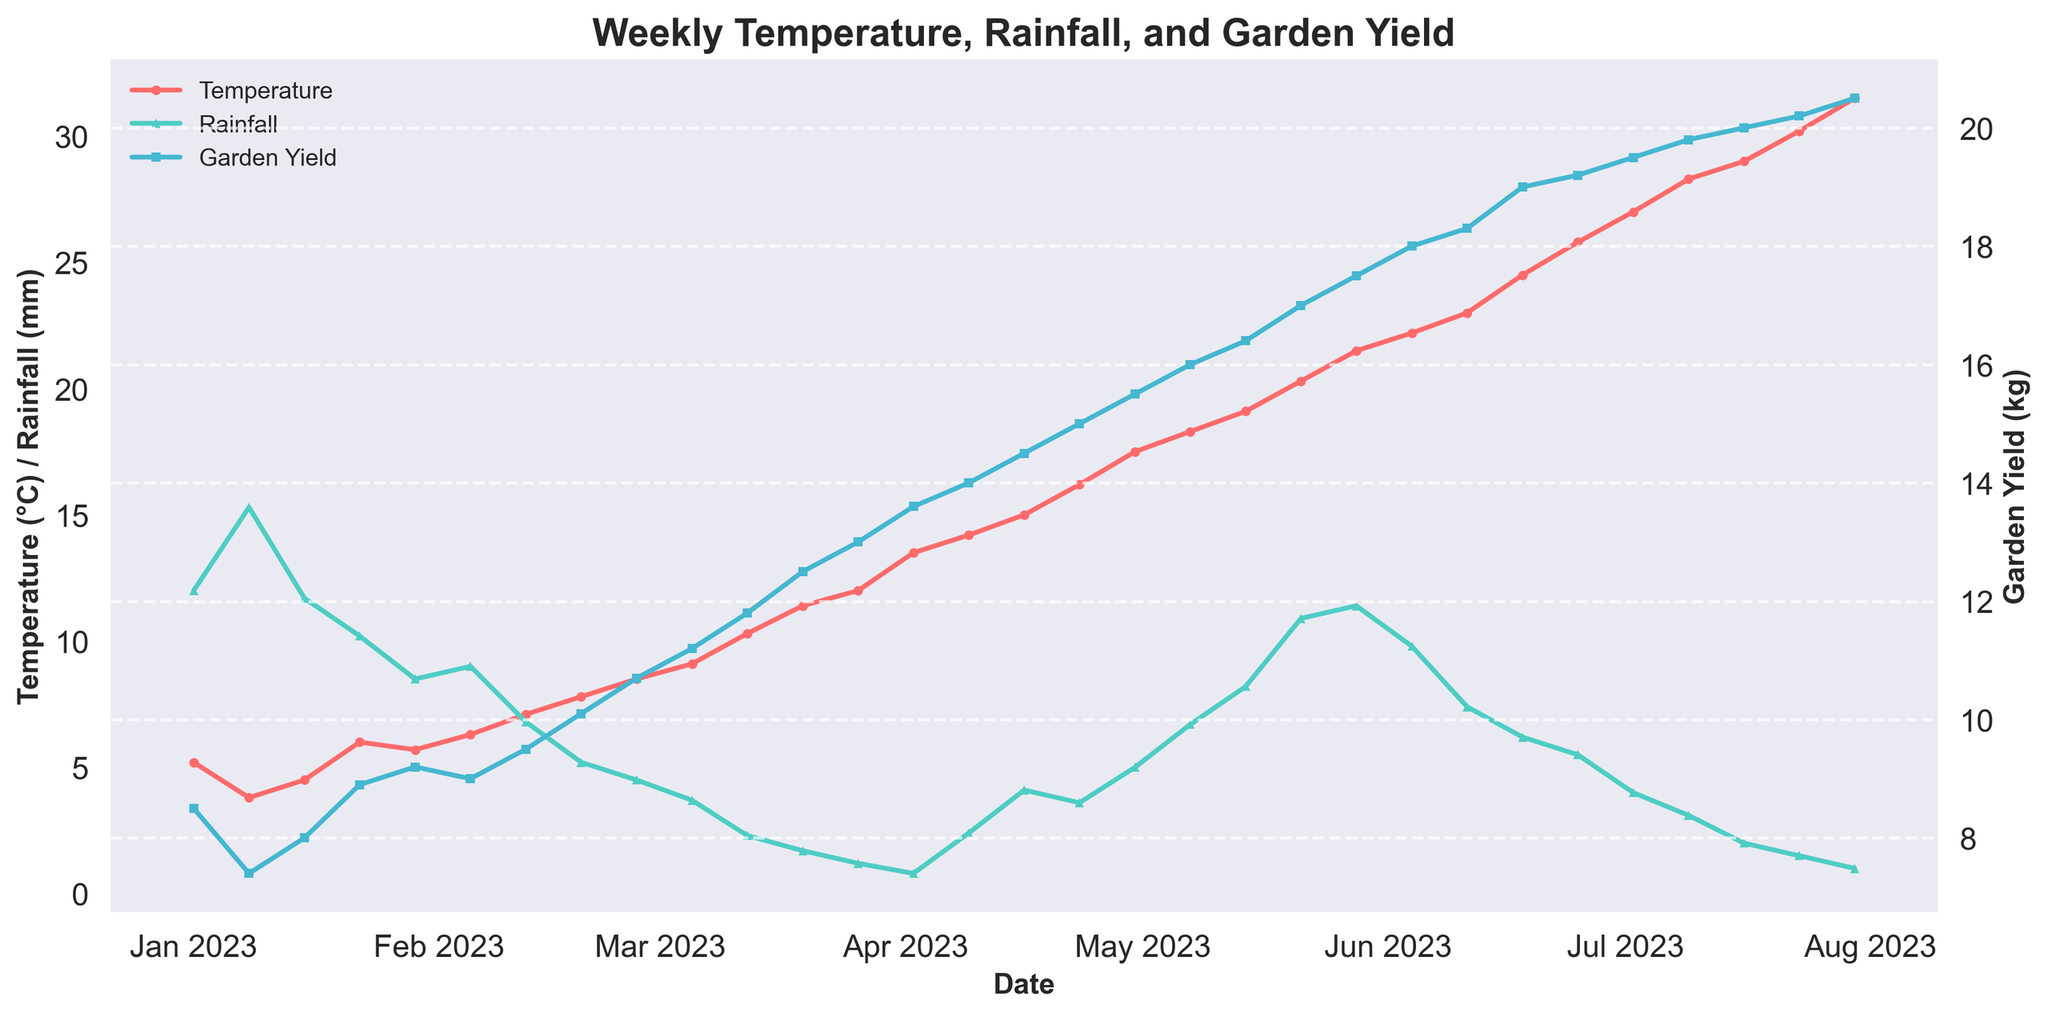What is the title of the figure? The title of the figure is usually found at the top of the plot and is used to describe the contents of the figure. In this case, it is written in bold and larger font size.
Answer: Weekly Temperature, Rainfall, and Garden Yield What are the units for temperature and rainfall on the left y-axis? The left y-axis typically displays units for the different variables it represents. In this case, the y-axis label should mention the units used for Temperature and Rainfall.
Answer: °C and mm What trends do you observe in garden yield from January to July 2023? By following the line plot for garden yield over time, it is clear that the garden yield consistently increases from the beginning of January to the end of July.
Answer: Increases On which date did the garden yield first exceed 10 kg? To find this, observe the 'Garden Yield (kg)' line and identify the first date at which it crosses the 10 kg mark. This can be checked by the data points along the x-axis.
Answer: 2023-02-26 Compare the temperature and rainfall trends from March to April. Examine the lines representing temperature and rainfall during the months of March and April. Note that temperature increases while rainfall decreases over these months.
Answer: Temperature increases, Rainfall decreases What was the highest garden yield recorded, and when did it occur? Locate the peak of the 'Garden Yield (kg)' line on the plot and look at the corresponding date. This requires identifying the maximum point for the garden yield.
Answer: 20.5 kg on 2023-07-30 During which month did the rainfall appear to be at its lowest, and what could be the possible impact on garden yield? Analyze the 'Rainfall (mm)' line to find the lowest point, then observe any correlation with the 'Garden Yield (kg)' line. The lowest rainfall appears around July, where the garden yield is high despite low rainfall.
Answer: July, with minimal impact (yield still high) How does temperature affect garden yield over the observed period? Correlate the trend lines for temperature and garden yield. As temperature increases, garden yield also appears to increase, indicating a positive relationship.
Answer: Positive relationship - both increase What is the average garden yield for the month of March 2023? Identify the garden yield values for all the weeks in March, sum them up and divide by the number of these weeks (4). This involves reading individual values and calculating the mean.
Answer: (11.2 + 11.8 + 12.5 + 13.0) / 4 = 12.125 kg Compare the garden yield recorded on 2023-03-26 with that recorded on 2023-04-02. Which one is higher and by how much? Locate the yield values for these two dates from the 'Garden Yield (kg)' line and subtract the smaller value from the larger one to find the difference.
Answer: 13.6 kg on 2023-04-02 is higher by 0.6 kg compared to 13.0 kg on 2023-03-26 